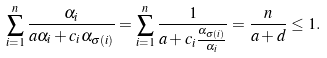<formula> <loc_0><loc_0><loc_500><loc_500>\sum _ { i = 1 } ^ { n } \frac { \alpha _ { i } } { a \alpha _ { i } + c _ { i } \alpha _ { \sigma ( i ) } } = \sum _ { i = 1 } ^ { n } \frac { 1 } { a + c _ { i } \frac { \alpha _ { \sigma ( i ) } } { \alpha _ { i } } } = \frac { n } { a + d } \leq 1 .</formula> 